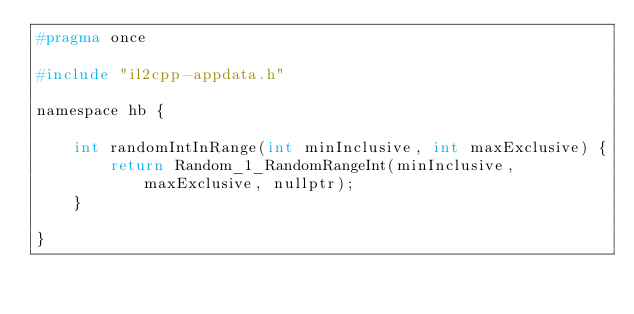<code> <loc_0><loc_0><loc_500><loc_500><_C_>#pragma once

#include "il2cpp-appdata.h"

namespace hb {

    int randomIntInRange(int minInclusive, int maxExclusive) {
        return Random_1_RandomRangeInt(minInclusive, maxExclusive, nullptr);
    }

}
</code> 